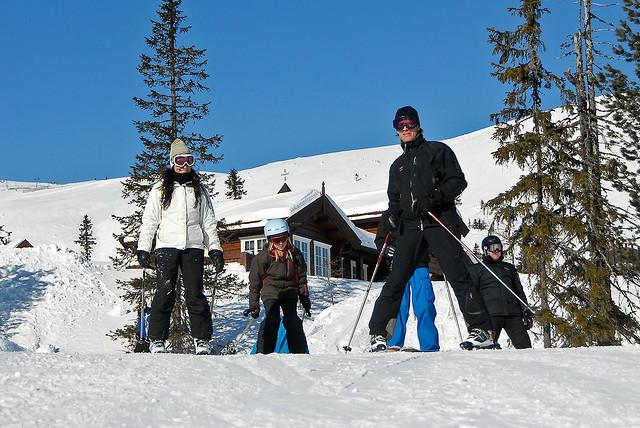Why are the children's heads covered? safety 